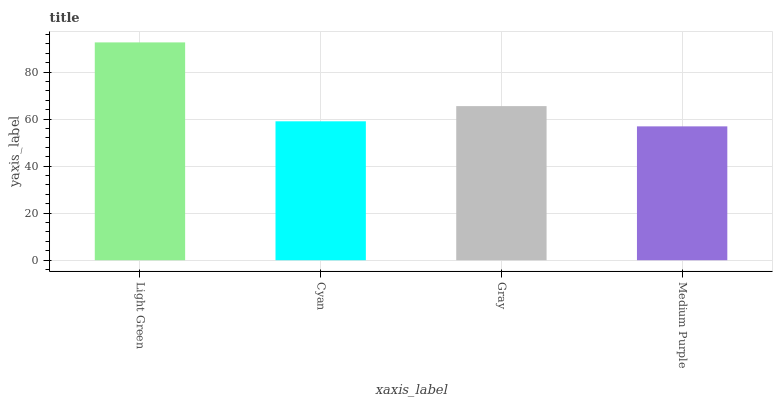Is Medium Purple the minimum?
Answer yes or no. Yes. Is Light Green the maximum?
Answer yes or no. Yes. Is Cyan the minimum?
Answer yes or no. No. Is Cyan the maximum?
Answer yes or no. No. Is Light Green greater than Cyan?
Answer yes or no. Yes. Is Cyan less than Light Green?
Answer yes or no. Yes. Is Cyan greater than Light Green?
Answer yes or no. No. Is Light Green less than Cyan?
Answer yes or no. No. Is Gray the high median?
Answer yes or no. Yes. Is Cyan the low median?
Answer yes or no. Yes. Is Light Green the high median?
Answer yes or no. No. Is Light Green the low median?
Answer yes or no. No. 